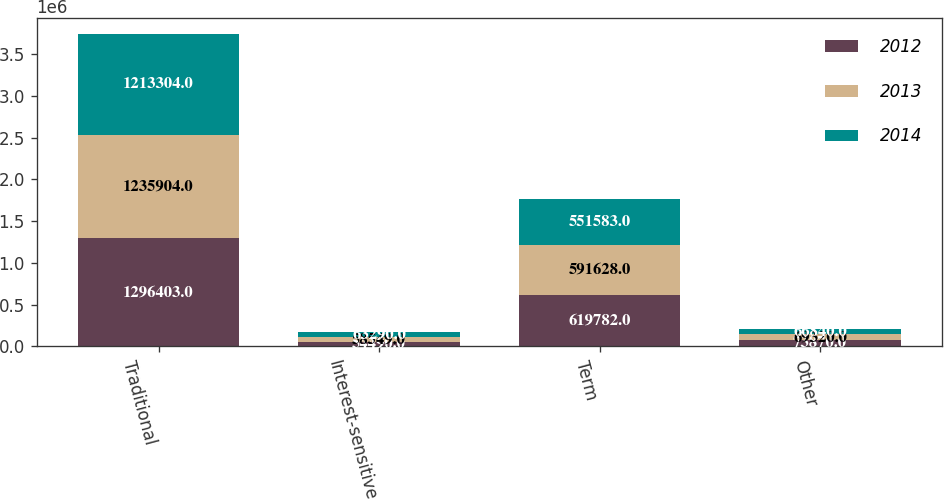Convert chart to OTSL. <chart><loc_0><loc_0><loc_500><loc_500><stacked_bar_chart><ecel><fcel>Traditional<fcel>Interest-sensitive<fcel>Term<fcel>Other<nl><fcel>2012<fcel>1.2964e+06<fcel>54490<fcel>619782<fcel>73870<nl><fcel>2013<fcel>1.2359e+06<fcel>58549<fcel>591628<fcel>69320<nl><fcel>2014<fcel>1.2133e+06<fcel>63290<fcel>551583<fcel>66840<nl></chart> 